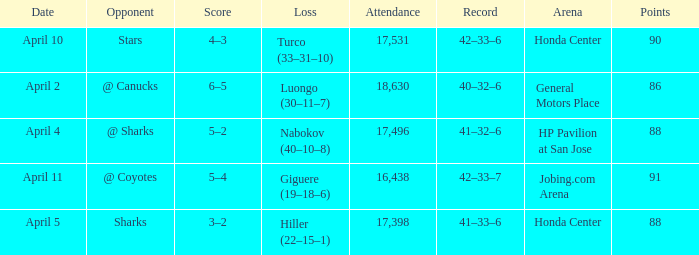Which Loss has a Record of 41–32–6? Nabokov (40–10–8). 